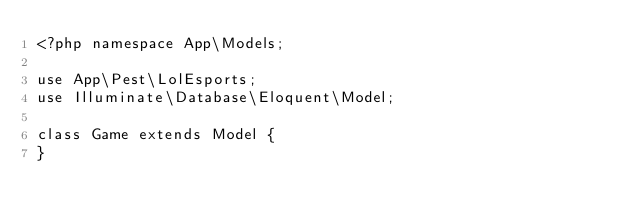<code> <loc_0><loc_0><loc_500><loc_500><_PHP_><?php namespace App\Models;

use App\Pest\LolEsports;
use Illuminate\Database\Eloquent\Model;

class Game extends Model {
}</code> 